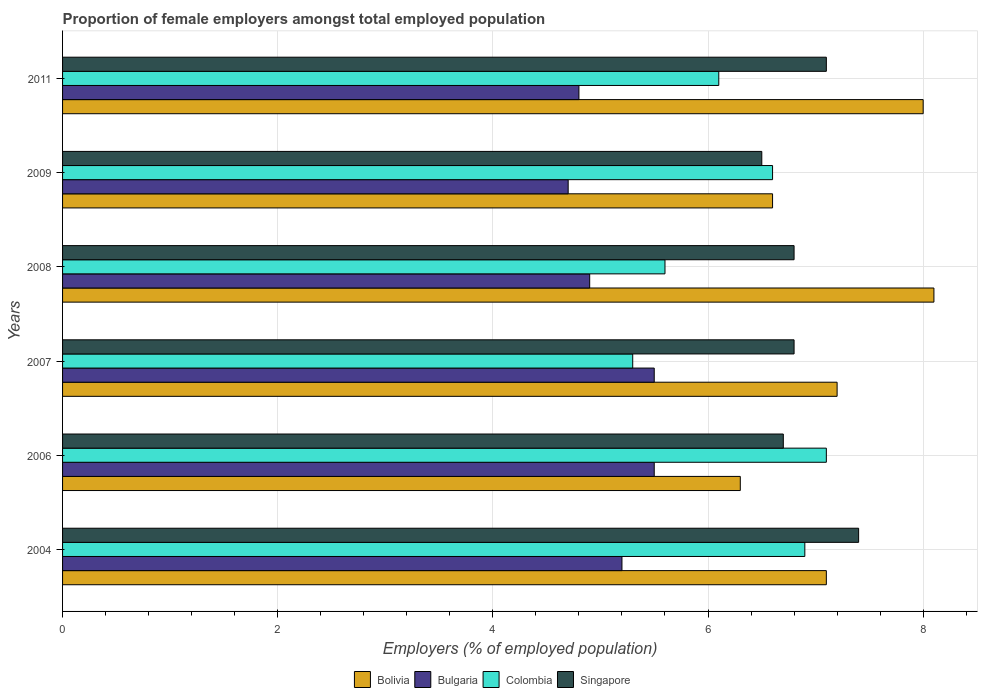How many different coloured bars are there?
Keep it short and to the point. 4. How many groups of bars are there?
Offer a terse response. 6. Are the number of bars per tick equal to the number of legend labels?
Your answer should be very brief. Yes. Are the number of bars on each tick of the Y-axis equal?
Your answer should be compact. Yes. What is the label of the 4th group of bars from the top?
Your answer should be compact. 2007. What is the proportion of female employers in Bulgaria in 2011?
Provide a short and direct response. 4.8. Across all years, what is the maximum proportion of female employers in Singapore?
Give a very brief answer. 7.4. Across all years, what is the minimum proportion of female employers in Bulgaria?
Provide a succinct answer. 4.7. In which year was the proportion of female employers in Colombia maximum?
Give a very brief answer. 2006. What is the total proportion of female employers in Bolivia in the graph?
Give a very brief answer. 43.3. What is the difference between the proportion of female employers in Singapore in 2004 and that in 2006?
Keep it short and to the point. 0.7. What is the difference between the proportion of female employers in Bulgaria in 2011 and the proportion of female employers in Singapore in 2008?
Provide a short and direct response. -2. What is the average proportion of female employers in Bolivia per year?
Provide a succinct answer. 7.22. In the year 2011, what is the difference between the proportion of female employers in Bolivia and proportion of female employers in Colombia?
Provide a succinct answer. 1.9. What is the ratio of the proportion of female employers in Singapore in 2006 to that in 2007?
Give a very brief answer. 0.99. Is the difference between the proportion of female employers in Bolivia in 2007 and 2011 greater than the difference between the proportion of female employers in Colombia in 2007 and 2011?
Ensure brevity in your answer.  No. What is the difference between the highest and the second highest proportion of female employers in Bulgaria?
Make the answer very short. 0. What is the difference between the highest and the lowest proportion of female employers in Bulgaria?
Keep it short and to the point. 0.8. In how many years, is the proportion of female employers in Colombia greater than the average proportion of female employers in Colombia taken over all years?
Your answer should be very brief. 3. Is the sum of the proportion of female employers in Bulgaria in 2004 and 2006 greater than the maximum proportion of female employers in Colombia across all years?
Keep it short and to the point. Yes. Is it the case that in every year, the sum of the proportion of female employers in Bolivia and proportion of female employers in Colombia is greater than the sum of proportion of female employers in Singapore and proportion of female employers in Bulgaria?
Your answer should be very brief. Yes. What does the 1st bar from the top in 2009 represents?
Your answer should be very brief. Singapore. How many bars are there?
Give a very brief answer. 24. How many years are there in the graph?
Your answer should be compact. 6. What is the difference between two consecutive major ticks on the X-axis?
Ensure brevity in your answer.  2. Are the values on the major ticks of X-axis written in scientific E-notation?
Provide a short and direct response. No. Does the graph contain any zero values?
Provide a short and direct response. No. How many legend labels are there?
Ensure brevity in your answer.  4. What is the title of the graph?
Keep it short and to the point. Proportion of female employers amongst total employed population. Does "Gambia, The" appear as one of the legend labels in the graph?
Make the answer very short. No. What is the label or title of the X-axis?
Provide a succinct answer. Employers (% of employed population). What is the Employers (% of employed population) in Bolivia in 2004?
Ensure brevity in your answer.  7.1. What is the Employers (% of employed population) of Bulgaria in 2004?
Your response must be concise. 5.2. What is the Employers (% of employed population) in Colombia in 2004?
Ensure brevity in your answer.  6.9. What is the Employers (% of employed population) in Singapore in 2004?
Keep it short and to the point. 7.4. What is the Employers (% of employed population) in Bolivia in 2006?
Offer a very short reply. 6.3. What is the Employers (% of employed population) of Bulgaria in 2006?
Provide a succinct answer. 5.5. What is the Employers (% of employed population) in Colombia in 2006?
Offer a terse response. 7.1. What is the Employers (% of employed population) in Singapore in 2006?
Offer a very short reply. 6.7. What is the Employers (% of employed population) in Bolivia in 2007?
Your answer should be very brief. 7.2. What is the Employers (% of employed population) of Colombia in 2007?
Your answer should be compact. 5.3. What is the Employers (% of employed population) of Singapore in 2007?
Your answer should be very brief. 6.8. What is the Employers (% of employed population) of Bolivia in 2008?
Offer a very short reply. 8.1. What is the Employers (% of employed population) in Bulgaria in 2008?
Your answer should be very brief. 4.9. What is the Employers (% of employed population) in Colombia in 2008?
Make the answer very short. 5.6. What is the Employers (% of employed population) in Singapore in 2008?
Ensure brevity in your answer.  6.8. What is the Employers (% of employed population) in Bolivia in 2009?
Your answer should be compact. 6.6. What is the Employers (% of employed population) in Bulgaria in 2009?
Provide a short and direct response. 4.7. What is the Employers (% of employed population) in Colombia in 2009?
Ensure brevity in your answer.  6.6. What is the Employers (% of employed population) of Bolivia in 2011?
Ensure brevity in your answer.  8. What is the Employers (% of employed population) in Bulgaria in 2011?
Provide a succinct answer. 4.8. What is the Employers (% of employed population) of Colombia in 2011?
Your answer should be compact. 6.1. What is the Employers (% of employed population) in Singapore in 2011?
Your response must be concise. 7.1. Across all years, what is the maximum Employers (% of employed population) of Bolivia?
Make the answer very short. 8.1. Across all years, what is the maximum Employers (% of employed population) of Colombia?
Your answer should be very brief. 7.1. Across all years, what is the maximum Employers (% of employed population) in Singapore?
Make the answer very short. 7.4. Across all years, what is the minimum Employers (% of employed population) in Bolivia?
Offer a very short reply. 6.3. Across all years, what is the minimum Employers (% of employed population) in Bulgaria?
Make the answer very short. 4.7. Across all years, what is the minimum Employers (% of employed population) of Colombia?
Make the answer very short. 5.3. What is the total Employers (% of employed population) in Bolivia in the graph?
Your answer should be compact. 43.3. What is the total Employers (% of employed population) of Bulgaria in the graph?
Keep it short and to the point. 30.6. What is the total Employers (% of employed population) in Colombia in the graph?
Offer a very short reply. 37.6. What is the total Employers (% of employed population) in Singapore in the graph?
Offer a very short reply. 41.3. What is the difference between the Employers (% of employed population) in Singapore in 2004 and that in 2006?
Ensure brevity in your answer.  0.7. What is the difference between the Employers (% of employed population) of Bolivia in 2004 and that in 2007?
Your answer should be compact. -0.1. What is the difference between the Employers (% of employed population) of Bulgaria in 2004 and that in 2007?
Your answer should be compact. -0.3. What is the difference between the Employers (% of employed population) of Colombia in 2004 and that in 2007?
Your answer should be compact. 1.6. What is the difference between the Employers (% of employed population) of Bolivia in 2004 and that in 2008?
Keep it short and to the point. -1. What is the difference between the Employers (% of employed population) of Bulgaria in 2004 and that in 2008?
Provide a short and direct response. 0.3. What is the difference between the Employers (% of employed population) in Colombia in 2004 and that in 2008?
Make the answer very short. 1.3. What is the difference between the Employers (% of employed population) of Bolivia in 2004 and that in 2009?
Provide a short and direct response. 0.5. What is the difference between the Employers (% of employed population) in Bulgaria in 2004 and that in 2009?
Keep it short and to the point. 0.5. What is the difference between the Employers (% of employed population) in Bolivia in 2004 and that in 2011?
Ensure brevity in your answer.  -0.9. What is the difference between the Employers (% of employed population) of Bulgaria in 2004 and that in 2011?
Offer a very short reply. 0.4. What is the difference between the Employers (% of employed population) of Colombia in 2004 and that in 2011?
Provide a short and direct response. 0.8. What is the difference between the Employers (% of employed population) in Singapore in 2004 and that in 2011?
Offer a terse response. 0.3. What is the difference between the Employers (% of employed population) of Bolivia in 2006 and that in 2007?
Your answer should be compact. -0.9. What is the difference between the Employers (% of employed population) in Colombia in 2006 and that in 2007?
Ensure brevity in your answer.  1.8. What is the difference between the Employers (% of employed population) of Bolivia in 2006 and that in 2008?
Offer a very short reply. -1.8. What is the difference between the Employers (% of employed population) in Singapore in 2006 and that in 2008?
Your answer should be compact. -0.1. What is the difference between the Employers (% of employed population) of Bolivia in 2006 and that in 2009?
Your answer should be very brief. -0.3. What is the difference between the Employers (% of employed population) of Singapore in 2006 and that in 2009?
Offer a very short reply. 0.2. What is the difference between the Employers (% of employed population) in Bolivia in 2006 and that in 2011?
Ensure brevity in your answer.  -1.7. What is the difference between the Employers (% of employed population) in Colombia in 2006 and that in 2011?
Give a very brief answer. 1. What is the difference between the Employers (% of employed population) in Bolivia in 2007 and that in 2008?
Your response must be concise. -0.9. What is the difference between the Employers (% of employed population) in Bulgaria in 2007 and that in 2008?
Provide a short and direct response. 0.6. What is the difference between the Employers (% of employed population) of Singapore in 2007 and that in 2008?
Offer a very short reply. 0. What is the difference between the Employers (% of employed population) in Bolivia in 2007 and that in 2009?
Your answer should be compact. 0.6. What is the difference between the Employers (% of employed population) of Bulgaria in 2007 and that in 2009?
Make the answer very short. 0.8. What is the difference between the Employers (% of employed population) of Singapore in 2007 and that in 2009?
Ensure brevity in your answer.  0.3. What is the difference between the Employers (% of employed population) of Bolivia in 2007 and that in 2011?
Your response must be concise. -0.8. What is the difference between the Employers (% of employed population) of Colombia in 2007 and that in 2011?
Provide a succinct answer. -0.8. What is the difference between the Employers (% of employed population) of Bulgaria in 2008 and that in 2009?
Your answer should be very brief. 0.2. What is the difference between the Employers (% of employed population) in Colombia in 2008 and that in 2009?
Offer a very short reply. -1. What is the difference between the Employers (% of employed population) of Bulgaria in 2008 and that in 2011?
Make the answer very short. 0.1. What is the difference between the Employers (% of employed population) in Singapore in 2008 and that in 2011?
Your answer should be compact. -0.3. What is the difference between the Employers (% of employed population) of Bolivia in 2009 and that in 2011?
Your response must be concise. -1.4. What is the difference between the Employers (% of employed population) in Colombia in 2009 and that in 2011?
Give a very brief answer. 0.5. What is the difference between the Employers (% of employed population) of Bolivia in 2004 and the Employers (% of employed population) of Bulgaria in 2006?
Make the answer very short. 1.6. What is the difference between the Employers (% of employed population) in Bolivia in 2004 and the Employers (% of employed population) in Colombia in 2006?
Keep it short and to the point. 0. What is the difference between the Employers (% of employed population) in Bolivia in 2004 and the Employers (% of employed population) in Singapore in 2006?
Keep it short and to the point. 0.4. What is the difference between the Employers (% of employed population) of Bulgaria in 2004 and the Employers (% of employed population) of Colombia in 2006?
Offer a terse response. -1.9. What is the difference between the Employers (% of employed population) of Colombia in 2004 and the Employers (% of employed population) of Singapore in 2006?
Offer a very short reply. 0.2. What is the difference between the Employers (% of employed population) in Bolivia in 2004 and the Employers (% of employed population) in Bulgaria in 2007?
Give a very brief answer. 1.6. What is the difference between the Employers (% of employed population) in Bolivia in 2004 and the Employers (% of employed population) in Colombia in 2007?
Give a very brief answer. 1.8. What is the difference between the Employers (% of employed population) of Bulgaria in 2004 and the Employers (% of employed population) of Singapore in 2007?
Provide a succinct answer. -1.6. What is the difference between the Employers (% of employed population) in Colombia in 2004 and the Employers (% of employed population) in Singapore in 2007?
Your response must be concise. 0.1. What is the difference between the Employers (% of employed population) of Bolivia in 2004 and the Employers (% of employed population) of Bulgaria in 2008?
Your response must be concise. 2.2. What is the difference between the Employers (% of employed population) of Bolivia in 2004 and the Employers (% of employed population) of Colombia in 2008?
Give a very brief answer. 1.5. What is the difference between the Employers (% of employed population) in Bolivia in 2004 and the Employers (% of employed population) in Singapore in 2008?
Keep it short and to the point. 0.3. What is the difference between the Employers (% of employed population) in Bulgaria in 2004 and the Employers (% of employed population) in Colombia in 2008?
Make the answer very short. -0.4. What is the difference between the Employers (% of employed population) of Colombia in 2004 and the Employers (% of employed population) of Singapore in 2008?
Provide a short and direct response. 0.1. What is the difference between the Employers (% of employed population) in Bolivia in 2004 and the Employers (% of employed population) in Bulgaria in 2009?
Your answer should be compact. 2.4. What is the difference between the Employers (% of employed population) of Bolivia in 2004 and the Employers (% of employed population) of Singapore in 2009?
Provide a succinct answer. 0.6. What is the difference between the Employers (% of employed population) in Bulgaria in 2004 and the Employers (% of employed population) in Colombia in 2009?
Offer a very short reply. -1.4. What is the difference between the Employers (% of employed population) in Bulgaria in 2004 and the Employers (% of employed population) in Singapore in 2009?
Make the answer very short. -1.3. What is the difference between the Employers (% of employed population) of Colombia in 2004 and the Employers (% of employed population) of Singapore in 2009?
Your response must be concise. 0.4. What is the difference between the Employers (% of employed population) of Bolivia in 2004 and the Employers (% of employed population) of Bulgaria in 2011?
Provide a short and direct response. 2.3. What is the difference between the Employers (% of employed population) in Colombia in 2004 and the Employers (% of employed population) in Singapore in 2011?
Your answer should be very brief. -0.2. What is the difference between the Employers (% of employed population) of Bulgaria in 2006 and the Employers (% of employed population) of Colombia in 2007?
Provide a succinct answer. 0.2. What is the difference between the Employers (% of employed population) of Bulgaria in 2006 and the Employers (% of employed population) of Singapore in 2007?
Your answer should be compact. -1.3. What is the difference between the Employers (% of employed population) in Colombia in 2006 and the Employers (% of employed population) in Singapore in 2007?
Your answer should be very brief. 0.3. What is the difference between the Employers (% of employed population) of Bolivia in 2006 and the Employers (% of employed population) of Colombia in 2008?
Provide a short and direct response. 0.7. What is the difference between the Employers (% of employed population) in Bulgaria in 2006 and the Employers (% of employed population) in Colombia in 2008?
Offer a very short reply. -0.1. What is the difference between the Employers (% of employed population) in Bulgaria in 2006 and the Employers (% of employed population) in Singapore in 2008?
Keep it short and to the point. -1.3. What is the difference between the Employers (% of employed population) of Bolivia in 2006 and the Employers (% of employed population) of Singapore in 2009?
Make the answer very short. -0.2. What is the difference between the Employers (% of employed population) of Bulgaria in 2006 and the Employers (% of employed population) of Colombia in 2009?
Offer a terse response. -1.1. What is the difference between the Employers (% of employed population) of Bolivia in 2006 and the Employers (% of employed population) of Bulgaria in 2011?
Keep it short and to the point. 1.5. What is the difference between the Employers (% of employed population) in Bolivia in 2006 and the Employers (% of employed population) in Singapore in 2011?
Offer a very short reply. -0.8. What is the difference between the Employers (% of employed population) of Bulgaria in 2006 and the Employers (% of employed population) of Colombia in 2011?
Your answer should be compact. -0.6. What is the difference between the Employers (% of employed population) of Bolivia in 2007 and the Employers (% of employed population) of Bulgaria in 2008?
Provide a succinct answer. 2.3. What is the difference between the Employers (% of employed population) in Bolivia in 2007 and the Employers (% of employed population) in Colombia in 2008?
Give a very brief answer. 1.6. What is the difference between the Employers (% of employed population) of Bolivia in 2007 and the Employers (% of employed population) of Singapore in 2008?
Keep it short and to the point. 0.4. What is the difference between the Employers (% of employed population) in Colombia in 2007 and the Employers (% of employed population) in Singapore in 2008?
Offer a very short reply. -1.5. What is the difference between the Employers (% of employed population) of Bolivia in 2007 and the Employers (% of employed population) of Bulgaria in 2009?
Keep it short and to the point. 2.5. What is the difference between the Employers (% of employed population) of Bolivia in 2007 and the Employers (% of employed population) of Colombia in 2009?
Ensure brevity in your answer.  0.6. What is the difference between the Employers (% of employed population) in Bolivia in 2007 and the Employers (% of employed population) in Singapore in 2009?
Ensure brevity in your answer.  0.7. What is the difference between the Employers (% of employed population) in Bulgaria in 2007 and the Employers (% of employed population) in Colombia in 2009?
Offer a very short reply. -1.1. What is the difference between the Employers (% of employed population) of Bulgaria in 2007 and the Employers (% of employed population) of Singapore in 2009?
Provide a short and direct response. -1. What is the difference between the Employers (% of employed population) of Colombia in 2007 and the Employers (% of employed population) of Singapore in 2009?
Provide a succinct answer. -1.2. What is the difference between the Employers (% of employed population) in Bolivia in 2007 and the Employers (% of employed population) in Singapore in 2011?
Keep it short and to the point. 0.1. What is the difference between the Employers (% of employed population) of Bulgaria in 2007 and the Employers (% of employed population) of Colombia in 2011?
Provide a succinct answer. -0.6. What is the difference between the Employers (% of employed population) of Colombia in 2007 and the Employers (% of employed population) of Singapore in 2011?
Ensure brevity in your answer.  -1.8. What is the difference between the Employers (% of employed population) in Bolivia in 2008 and the Employers (% of employed population) in Colombia in 2009?
Your answer should be compact. 1.5. What is the difference between the Employers (% of employed population) in Bolivia in 2008 and the Employers (% of employed population) in Singapore in 2009?
Provide a succinct answer. 1.6. What is the difference between the Employers (% of employed population) in Bulgaria in 2008 and the Employers (% of employed population) in Colombia in 2009?
Make the answer very short. -1.7. What is the difference between the Employers (% of employed population) in Bolivia in 2008 and the Employers (% of employed population) in Bulgaria in 2011?
Provide a succinct answer. 3.3. What is the difference between the Employers (% of employed population) of Bolivia in 2008 and the Employers (% of employed population) of Colombia in 2011?
Give a very brief answer. 2. What is the difference between the Employers (% of employed population) of Bulgaria in 2008 and the Employers (% of employed population) of Colombia in 2011?
Provide a short and direct response. -1.2. What is the difference between the Employers (% of employed population) of Bulgaria in 2008 and the Employers (% of employed population) of Singapore in 2011?
Ensure brevity in your answer.  -2.2. What is the difference between the Employers (% of employed population) in Colombia in 2008 and the Employers (% of employed population) in Singapore in 2011?
Your response must be concise. -1.5. What is the difference between the Employers (% of employed population) in Bolivia in 2009 and the Employers (% of employed population) in Bulgaria in 2011?
Ensure brevity in your answer.  1.8. What is the difference between the Employers (% of employed population) in Bolivia in 2009 and the Employers (% of employed population) in Colombia in 2011?
Give a very brief answer. 0.5. What is the difference between the Employers (% of employed population) of Bolivia in 2009 and the Employers (% of employed population) of Singapore in 2011?
Keep it short and to the point. -0.5. What is the difference between the Employers (% of employed population) of Bulgaria in 2009 and the Employers (% of employed population) of Singapore in 2011?
Offer a very short reply. -2.4. What is the difference between the Employers (% of employed population) of Colombia in 2009 and the Employers (% of employed population) of Singapore in 2011?
Your answer should be very brief. -0.5. What is the average Employers (% of employed population) in Bolivia per year?
Make the answer very short. 7.22. What is the average Employers (% of employed population) in Colombia per year?
Provide a succinct answer. 6.27. What is the average Employers (% of employed population) in Singapore per year?
Keep it short and to the point. 6.88. In the year 2004, what is the difference between the Employers (% of employed population) of Bolivia and Employers (% of employed population) of Bulgaria?
Give a very brief answer. 1.9. In the year 2004, what is the difference between the Employers (% of employed population) of Bulgaria and Employers (% of employed population) of Colombia?
Give a very brief answer. -1.7. In the year 2004, what is the difference between the Employers (% of employed population) of Bulgaria and Employers (% of employed population) of Singapore?
Give a very brief answer. -2.2. In the year 2004, what is the difference between the Employers (% of employed population) in Colombia and Employers (% of employed population) in Singapore?
Keep it short and to the point. -0.5. In the year 2006, what is the difference between the Employers (% of employed population) in Bolivia and Employers (% of employed population) in Colombia?
Provide a short and direct response. -0.8. In the year 2006, what is the difference between the Employers (% of employed population) of Bulgaria and Employers (% of employed population) of Colombia?
Keep it short and to the point. -1.6. In the year 2006, what is the difference between the Employers (% of employed population) in Bulgaria and Employers (% of employed population) in Singapore?
Your answer should be very brief. -1.2. In the year 2007, what is the difference between the Employers (% of employed population) of Bolivia and Employers (% of employed population) of Bulgaria?
Provide a short and direct response. 1.7. In the year 2007, what is the difference between the Employers (% of employed population) of Bolivia and Employers (% of employed population) of Colombia?
Offer a very short reply. 1.9. In the year 2007, what is the difference between the Employers (% of employed population) in Bolivia and Employers (% of employed population) in Singapore?
Keep it short and to the point. 0.4. In the year 2008, what is the difference between the Employers (% of employed population) of Bolivia and Employers (% of employed population) of Bulgaria?
Give a very brief answer. 3.2. In the year 2008, what is the difference between the Employers (% of employed population) of Bolivia and Employers (% of employed population) of Colombia?
Keep it short and to the point. 2.5. In the year 2008, what is the difference between the Employers (% of employed population) of Bulgaria and Employers (% of employed population) of Colombia?
Provide a short and direct response. -0.7. In the year 2009, what is the difference between the Employers (% of employed population) of Bolivia and Employers (% of employed population) of Singapore?
Your response must be concise. 0.1. In the year 2009, what is the difference between the Employers (% of employed population) in Colombia and Employers (% of employed population) in Singapore?
Ensure brevity in your answer.  0.1. In the year 2011, what is the difference between the Employers (% of employed population) in Bolivia and Employers (% of employed population) in Bulgaria?
Offer a very short reply. 3.2. In the year 2011, what is the difference between the Employers (% of employed population) in Bolivia and Employers (% of employed population) in Colombia?
Your answer should be compact. 1.9. What is the ratio of the Employers (% of employed population) of Bolivia in 2004 to that in 2006?
Give a very brief answer. 1.13. What is the ratio of the Employers (% of employed population) of Bulgaria in 2004 to that in 2006?
Keep it short and to the point. 0.95. What is the ratio of the Employers (% of employed population) in Colombia in 2004 to that in 2006?
Provide a short and direct response. 0.97. What is the ratio of the Employers (% of employed population) of Singapore in 2004 to that in 2006?
Your response must be concise. 1.1. What is the ratio of the Employers (% of employed population) in Bolivia in 2004 to that in 2007?
Make the answer very short. 0.99. What is the ratio of the Employers (% of employed population) of Bulgaria in 2004 to that in 2007?
Give a very brief answer. 0.95. What is the ratio of the Employers (% of employed population) in Colombia in 2004 to that in 2007?
Provide a short and direct response. 1.3. What is the ratio of the Employers (% of employed population) of Singapore in 2004 to that in 2007?
Offer a terse response. 1.09. What is the ratio of the Employers (% of employed population) in Bolivia in 2004 to that in 2008?
Your answer should be compact. 0.88. What is the ratio of the Employers (% of employed population) of Bulgaria in 2004 to that in 2008?
Your answer should be compact. 1.06. What is the ratio of the Employers (% of employed population) of Colombia in 2004 to that in 2008?
Provide a short and direct response. 1.23. What is the ratio of the Employers (% of employed population) of Singapore in 2004 to that in 2008?
Offer a terse response. 1.09. What is the ratio of the Employers (% of employed population) of Bolivia in 2004 to that in 2009?
Ensure brevity in your answer.  1.08. What is the ratio of the Employers (% of employed population) of Bulgaria in 2004 to that in 2009?
Offer a very short reply. 1.11. What is the ratio of the Employers (% of employed population) in Colombia in 2004 to that in 2009?
Your response must be concise. 1.05. What is the ratio of the Employers (% of employed population) of Singapore in 2004 to that in 2009?
Ensure brevity in your answer.  1.14. What is the ratio of the Employers (% of employed population) of Bolivia in 2004 to that in 2011?
Give a very brief answer. 0.89. What is the ratio of the Employers (% of employed population) of Bulgaria in 2004 to that in 2011?
Make the answer very short. 1.08. What is the ratio of the Employers (% of employed population) in Colombia in 2004 to that in 2011?
Make the answer very short. 1.13. What is the ratio of the Employers (% of employed population) in Singapore in 2004 to that in 2011?
Offer a terse response. 1.04. What is the ratio of the Employers (% of employed population) of Bulgaria in 2006 to that in 2007?
Give a very brief answer. 1. What is the ratio of the Employers (% of employed population) of Colombia in 2006 to that in 2007?
Offer a very short reply. 1.34. What is the ratio of the Employers (% of employed population) of Singapore in 2006 to that in 2007?
Offer a terse response. 0.99. What is the ratio of the Employers (% of employed population) of Bulgaria in 2006 to that in 2008?
Make the answer very short. 1.12. What is the ratio of the Employers (% of employed population) of Colombia in 2006 to that in 2008?
Provide a succinct answer. 1.27. What is the ratio of the Employers (% of employed population) in Bolivia in 2006 to that in 2009?
Provide a short and direct response. 0.95. What is the ratio of the Employers (% of employed population) in Bulgaria in 2006 to that in 2009?
Keep it short and to the point. 1.17. What is the ratio of the Employers (% of employed population) of Colombia in 2006 to that in 2009?
Ensure brevity in your answer.  1.08. What is the ratio of the Employers (% of employed population) of Singapore in 2006 to that in 2009?
Give a very brief answer. 1.03. What is the ratio of the Employers (% of employed population) in Bolivia in 2006 to that in 2011?
Keep it short and to the point. 0.79. What is the ratio of the Employers (% of employed population) of Bulgaria in 2006 to that in 2011?
Your answer should be compact. 1.15. What is the ratio of the Employers (% of employed population) of Colombia in 2006 to that in 2011?
Your answer should be very brief. 1.16. What is the ratio of the Employers (% of employed population) of Singapore in 2006 to that in 2011?
Provide a short and direct response. 0.94. What is the ratio of the Employers (% of employed population) of Bulgaria in 2007 to that in 2008?
Provide a short and direct response. 1.12. What is the ratio of the Employers (% of employed population) of Colombia in 2007 to that in 2008?
Keep it short and to the point. 0.95. What is the ratio of the Employers (% of employed population) of Singapore in 2007 to that in 2008?
Provide a short and direct response. 1. What is the ratio of the Employers (% of employed population) in Bolivia in 2007 to that in 2009?
Provide a succinct answer. 1.09. What is the ratio of the Employers (% of employed population) of Bulgaria in 2007 to that in 2009?
Give a very brief answer. 1.17. What is the ratio of the Employers (% of employed population) in Colombia in 2007 to that in 2009?
Make the answer very short. 0.8. What is the ratio of the Employers (% of employed population) in Singapore in 2007 to that in 2009?
Offer a very short reply. 1.05. What is the ratio of the Employers (% of employed population) of Bulgaria in 2007 to that in 2011?
Offer a terse response. 1.15. What is the ratio of the Employers (% of employed population) of Colombia in 2007 to that in 2011?
Ensure brevity in your answer.  0.87. What is the ratio of the Employers (% of employed population) of Singapore in 2007 to that in 2011?
Provide a succinct answer. 0.96. What is the ratio of the Employers (% of employed population) in Bolivia in 2008 to that in 2009?
Provide a succinct answer. 1.23. What is the ratio of the Employers (% of employed population) in Bulgaria in 2008 to that in 2009?
Your answer should be very brief. 1.04. What is the ratio of the Employers (% of employed population) in Colombia in 2008 to that in 2009?
Your answer should be very brief. 0.85. What is the ratio of the Employers (% of employed population) of Singapore in 2008 to that in 2009?
Your answer should be compact. 1.05. What is the ratio of the Employers (% of employed population) in Bolivia in 2008 to that in 2011?
Provide a short and direct response. 1.01. What is the ratio of the Employers (% of employed population) of Bulgaria in 2008 to that in 2011?
Ensure brevity in your answer.  1.02. What is the ratio of the Employers (% of employed population) of Colombia in 2008 to that in 2011?
Keep it short and to the point. 0.92. What is the ratio of the Employers (% of employed population) in Singapore in 2008 to that in 2011?
Make the answer very short. 0.96. What is the ratio of the Employers (% of employed population) in Bolivia in 2009 to that in 2011?
Your answer should be very brief. 0.82. What is the ratio of the Employers (% of employed population) in Bulgaria in 2009 to that in 2011?
Your answer should be very brief. 0.98. What is the ratio of the Employers (% of employed population) in Colombia in 2009 to that in 2011?
Offer a terse response. 1.08. What is the ratio of the Employers (% of employed population) in Singapore in 2009 to that in 2011?
Ensure brevity in your answer.  0.92. What is the difference between the highest and the second highest Employers (% of employed population) in Bulgaria?
Ensure brevity in your answer.  0. What is the difference between the highest and the second highest Employers (% of employed population) of Colombia?
Make the answer very short. 0.2. What is the difference between the highest and the second highest Employers (% of employed population) in Singapore?
Your answer should be very brief. 0.3. What is the difference between the highest and the lowest Employers (% of employed population) of Bolivia?
Offer a very short reply. 1.8. What is the difference between the highest and the lowest Employers (% of employed population) in Bulgaria?
Provide a short and direct response. 0.8. What is the difference between the highest and the lowest Employers (% of employed population) of Colombia?
Provide a short and direct response. 1.8. What is the difference between the highest and the lowest Employers (% of employed population) in Singapore?
Your answer should be very brief. 0.9. 